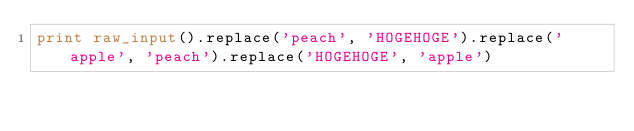Convert code to text. <code><loc_0><loc_0><loc_500><loc_500><_Python_>print raw_input().replace('peach', 'HOGEHOGE').replace('apple', 'peach').replace('HOGEHOGE', 'apple')</code> 